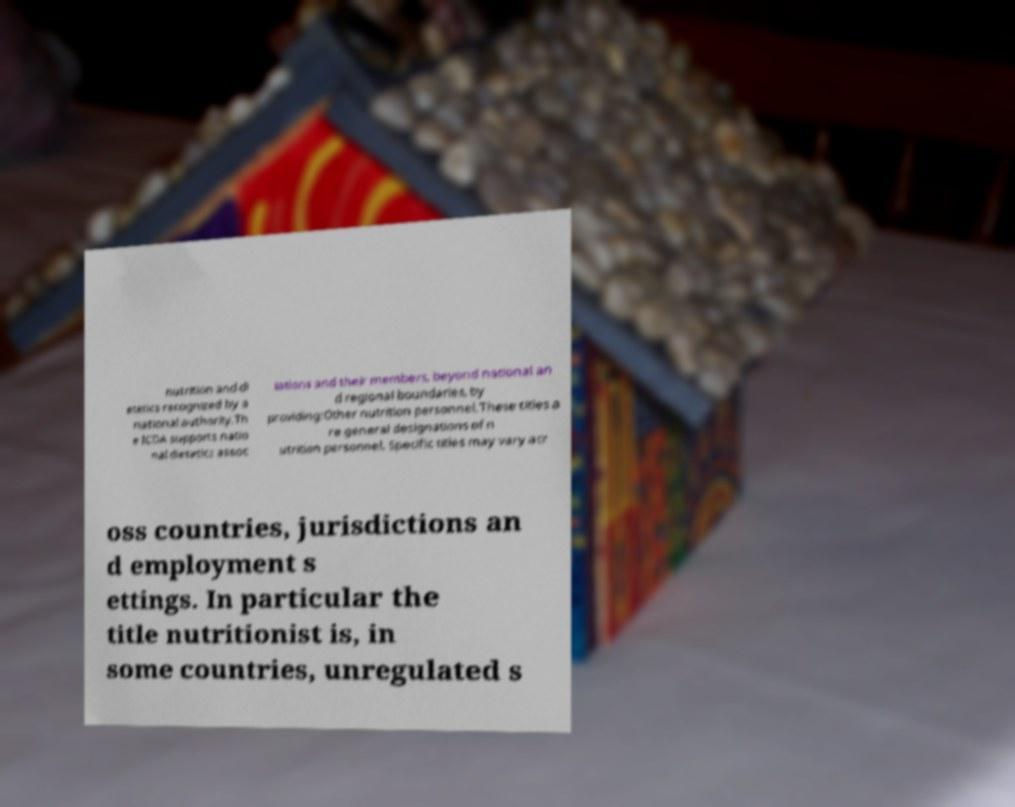Could you extract and type out the text from this image? nutrition and di etetics recognized by a national authority.Th e ICDA supports natio nal dietetics assoc iations and their members, beyond national an d regional boundaries, by providing:Other nutrition personnel.These titles a re general designations of n utrition personnel. Specific titles may vary acr oss countries, jurisdictions an d employment s ettings. In particular the title nutritionist is, in some countries, unregulated s 